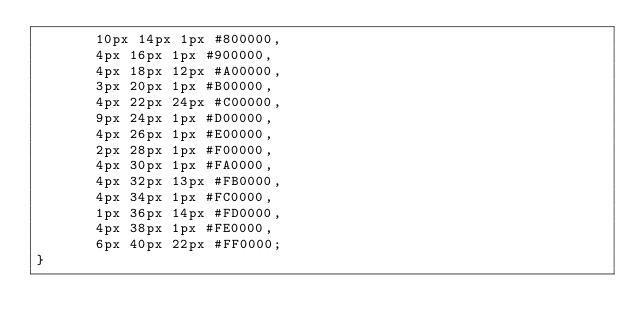<code> <loc_0><loc_0><loc_500><loc_500><_CSS_>       10px 14px 1px #800000,
       4px 16px 1px #900000,
       4px 18px 12px #A00000,
       3px 20px 1px #B00000,
       4px 22px 24px #C00000,
       9px 24px 1px #D00000,
       4px 26px 1px #E00000,
       2px 28px 1px #F00000,
       4px 30px 1px #FA0000,
       4px 32px 13px #FB0000,
       4px 34px 1px #FC0000,
       1px 36px 14px #FD0000,
       4px 38px 1px #FE0000,
       6px 40px 22px #FF0000;
}</code> 